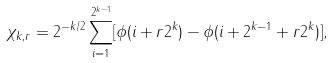Convert formula to latex. <formula><loc_0><loc_0><loc_500><loc_500>\chi _ { k , r } = 2 ^ { - k / 2 } \sum _ { i = 1 } ^ { 2 ^ { k - 1 } } [ \phi ( i + r 2 ^ { k } ) - \phi ( i + 2 ^ { k - 1 } + r 2 ^ { k } ) ] ,</formula> 